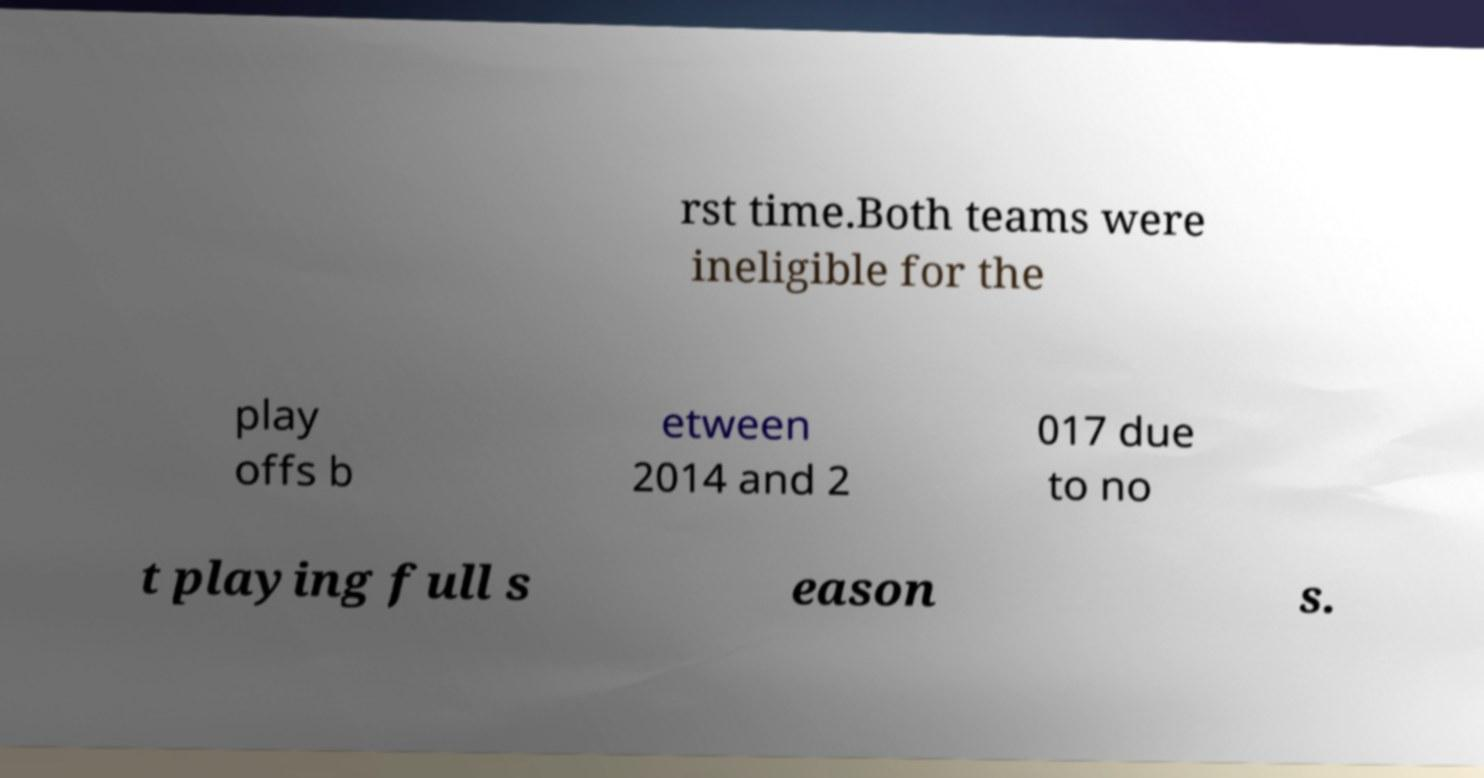There's text embedded in this image that I need extracted. Can you transcribe it verbatim? rst time.Both teams were ineligible for the play offs b etween 2014 and 2 017 due to no t playing full s eason s. 